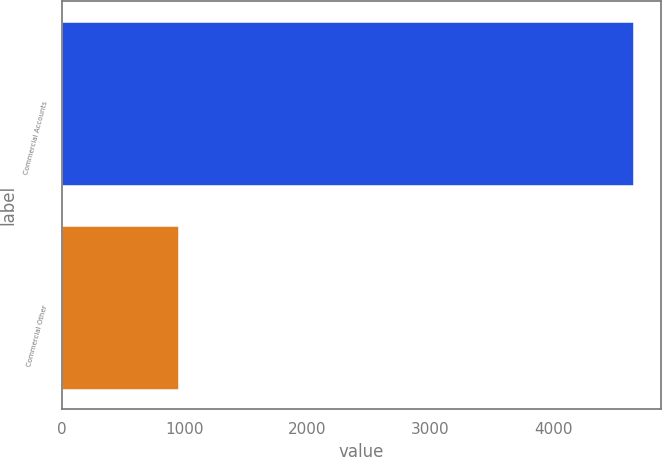Convert chart. <chart><loc_0><loc_0><loc_500><loc_500><bar_chart><fcel>Commercial Accounts<fcel>Commercial Other<nl><fcel>4648<fcel>947<nl></chart> 